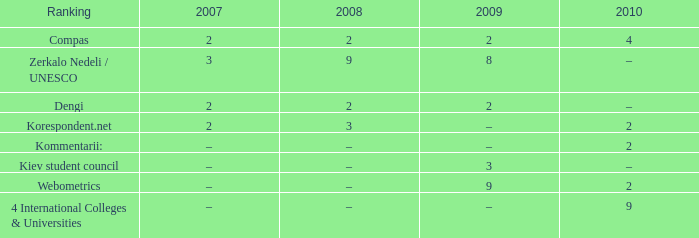What was the 2009 ranking for Webometrics? 9.0. 